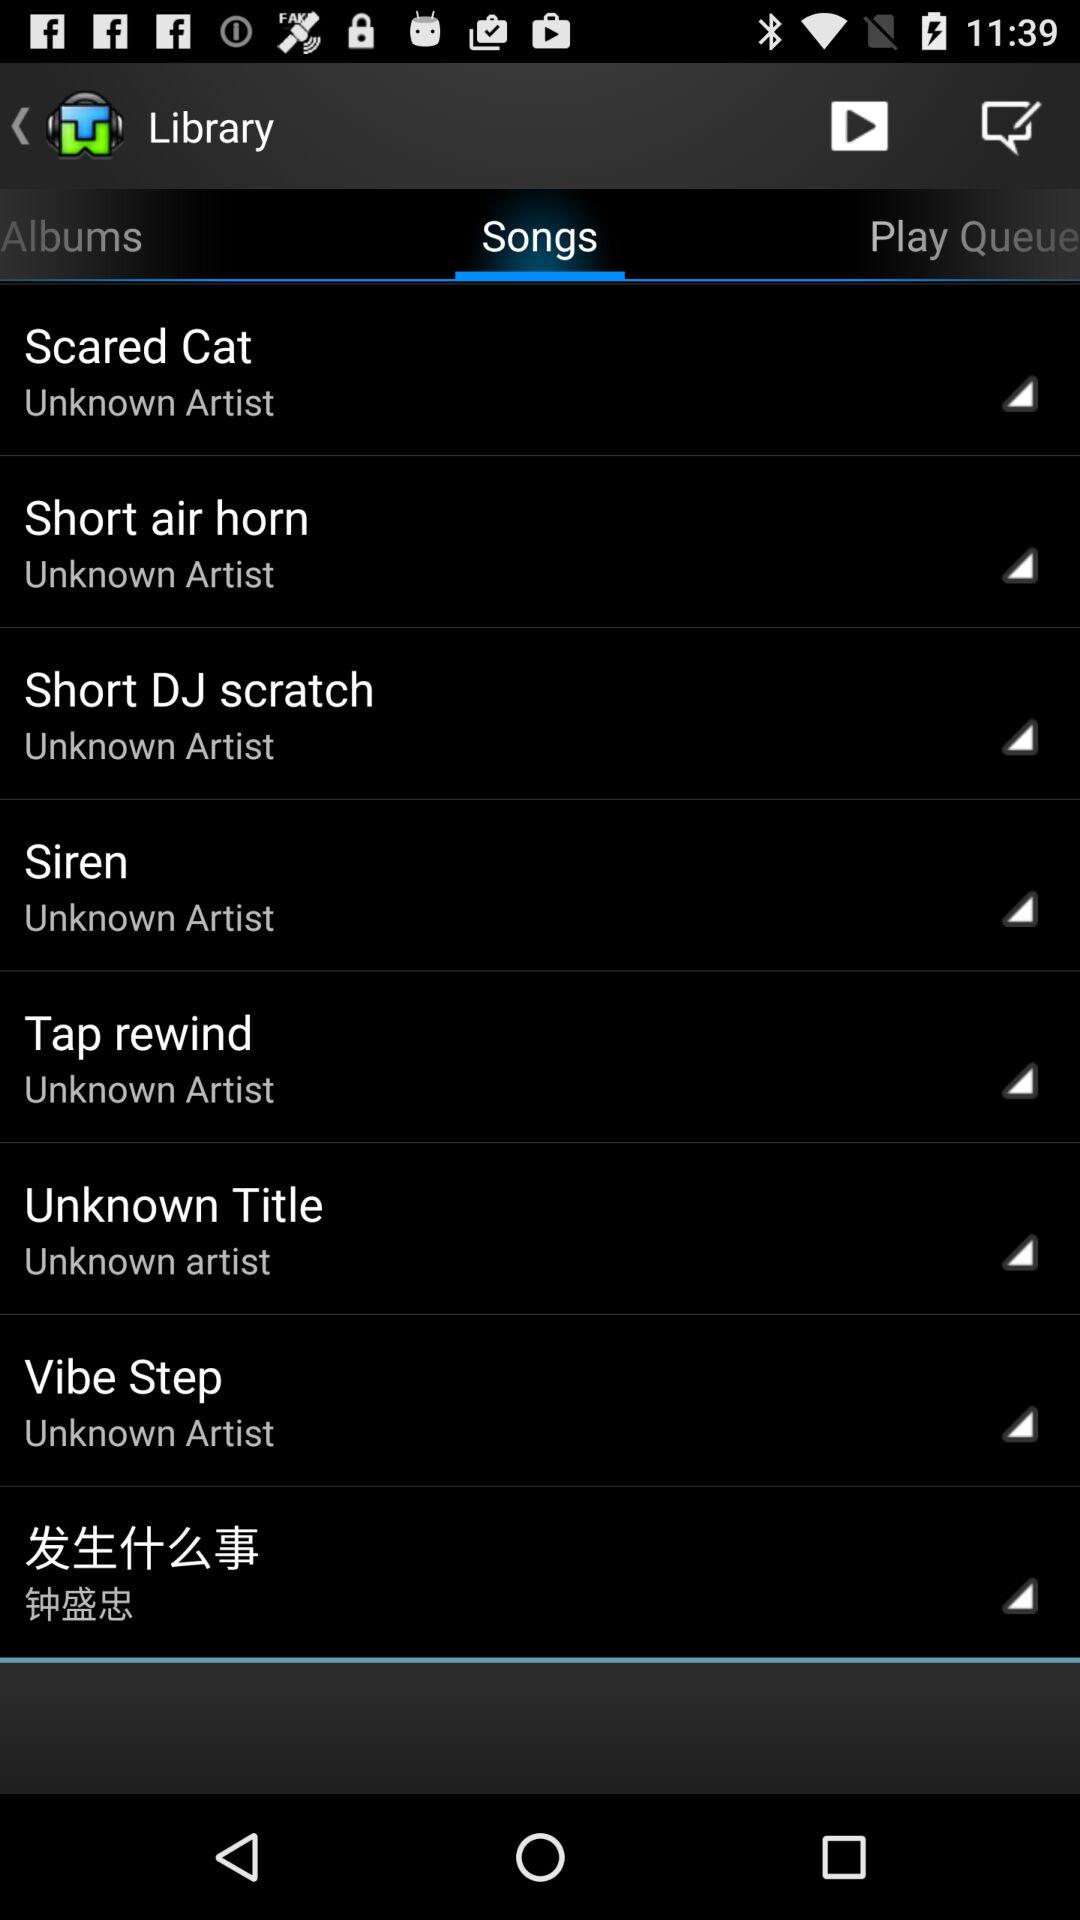Which tab is selected? The selected tab is "Songs". 